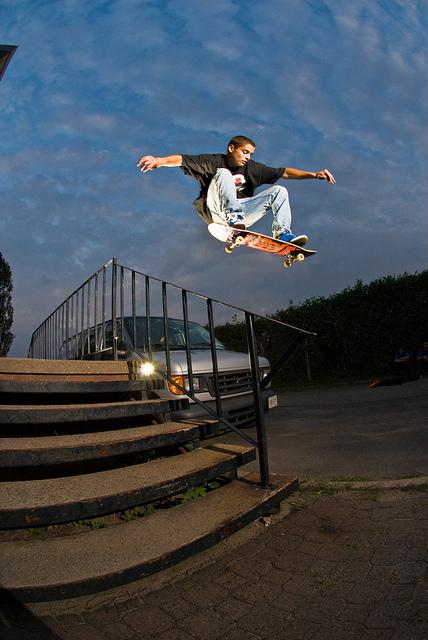The skateboarder would have to Ollie at least how high to clear the top of the railing? Please explain your reasoning. 3 feet. The railing is going to be three feet since it's waist high. 